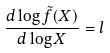<formula> <loc_0><loc_0><loc_500><loc_500>\frac { d \log \tilde { f } ( X ) } { d \log X } = l</formula> 